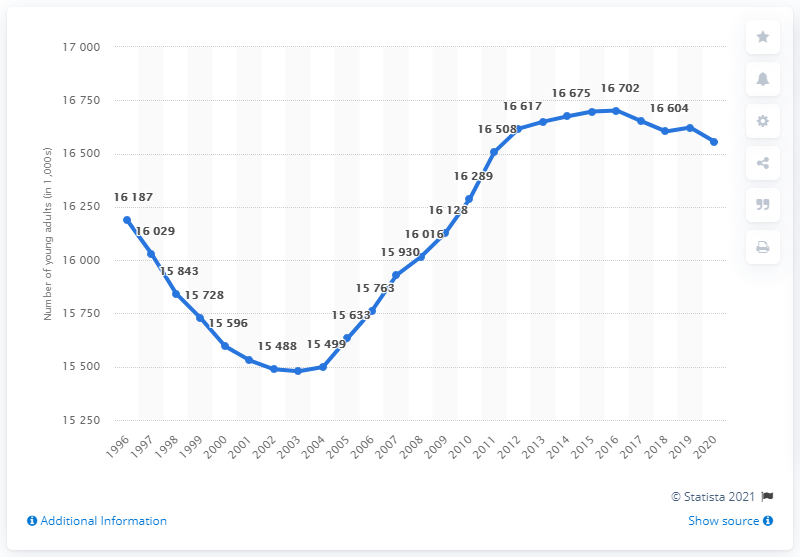Indicate a few pertinent items in this graphic. The peak number of young people living with their parents was in 2016. 